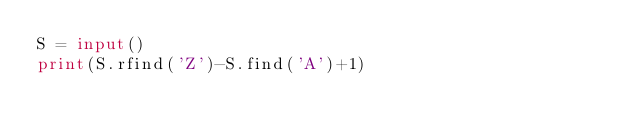Convert code to text. <code><loc_0><loc_0><loc_500><loc_500><_Python_>S = input()
print(S.rfind('Z')-S.find('A')+1)</code> 